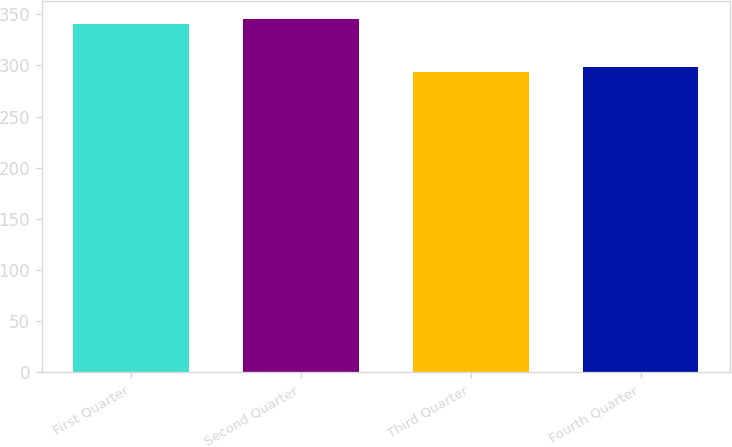<chart> <loc_0><loc_0><loc_500><loc_500><bar_chart><fcel>First Quarter<fcel>Second Quarter<fcel>Third Quarter<fcel>Fourth Quarter<nl><fcel>340.51<fcel>345.61<fcel>293.52<fcel>298.62<nl></chart> 